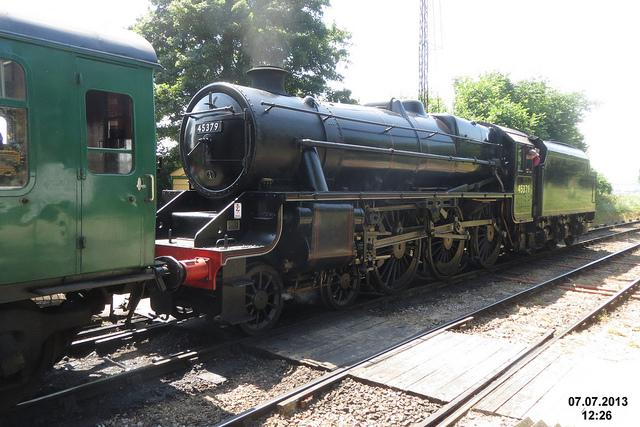Who invented this vehicle? Please explain your reasoning. richard trevithick. The inventor is richard. 